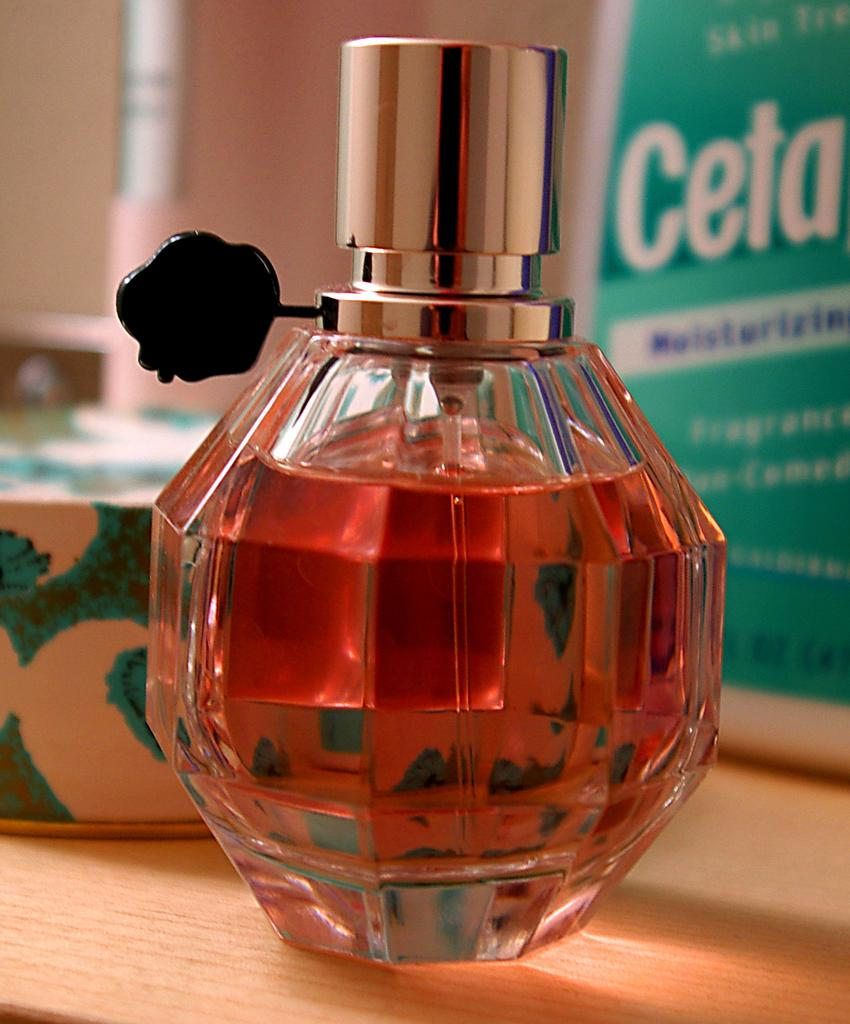<image>
Offer a succinct explanation of the picture presented. a bottle of perfume in front of a bottle reading Ceta 